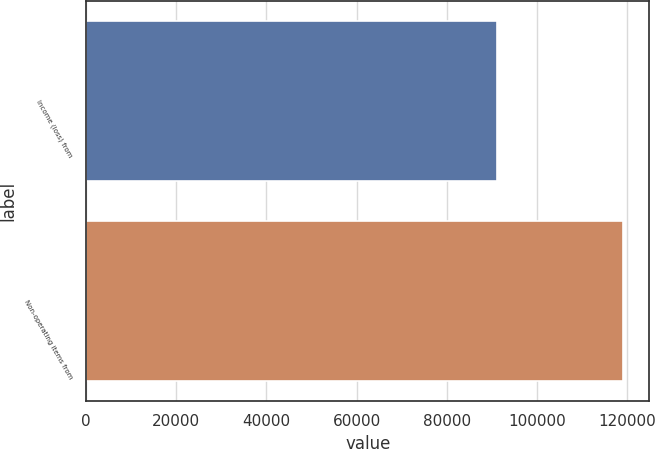<chart> <loc_0><loc_0><loc_500><loc_500><bar_chart><fcel>Income (loss) from<fcel>Non-operating items from<nl><fcel>91094<fcel>119013<nl></chart> 